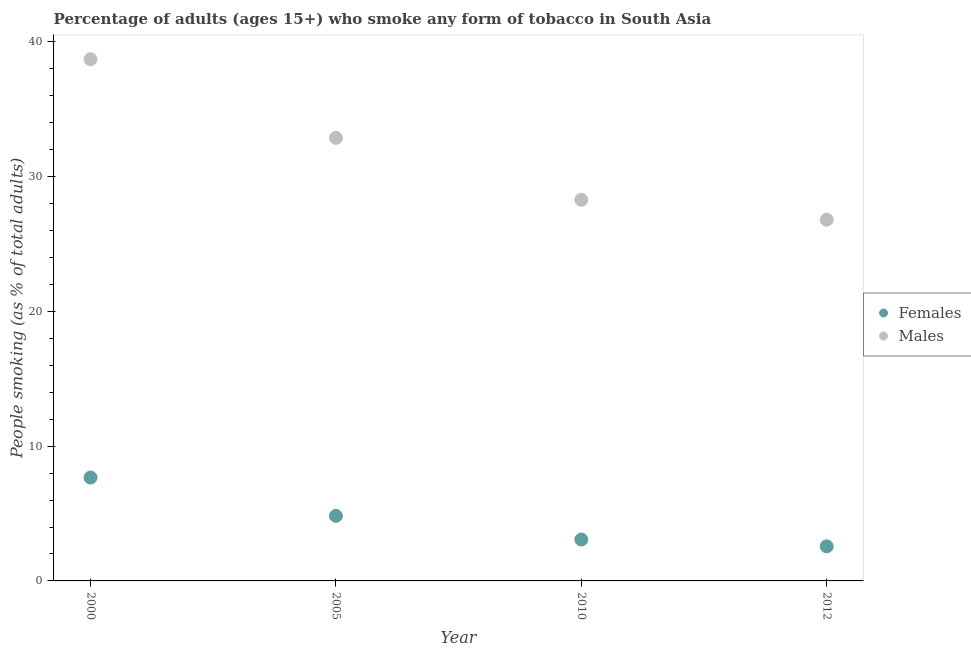How many different coloured dotlines are there?
Ensure brevity in your answer.  2. What is the percentage of males who smoke in 2010?
Provide a succinct answer. 28.29. Across all years, what is the maximum percentage of males who smoke?
Make the answer very short. 38.72. Across all years, what is the minimum percentage of females who smoke?
Offer a terse response. 2.56. In which year was the percentage of females who smoke maximum?
Keep it short and to the point. 2000. In which year was the percentage of males who smoke minimum?
Offer a very short reply. 2012. What is the total percentage of males who smoke in the graph?
Keep it short and to the point. 126.71. What is the difference between the percentage of females who smoke in 2010 and that in 2012?
Your answer should be compact. 0.51. What is the difference between the percentage of males who smoke in 2010 and the percentage of females who smoke in 2005?
Keep it short and to the point. 23.46. What is the average percentage of males who smoke per year?
Provide a short and direct response. 31.68. In the year 2005, what is the difference between the percentage of males who smoke and percentage of females who smoke?
Give a very brief answer. 28.06. What is the ratio of the percentage of males who smoke in 2005 to that in 2012?
Ensure brevity in your answer.  1.23. Is the difference between the percentage of females who smoke in 2000 and 2005 greater than the difference between the percentage of males who smoke in 2000 and 2005?
Ensure brevity in your answer.  No. What is the difference between the highest and the second highest percentage of males who smoke?
Your response must be concise. 5.83. What is the difference between the highest and the lowest percentage of males who smoke?
Provide a succinct answer. 11.91. Is the sum of the percentage of males who smoke in 2005 and 2010 greater than the maximum percentage of females who smoke across all years?
Ensure brevity in your answer.  Yes. Is the percentage of females who smoke strictly greater than the percentage of males who smoke over the years?
Provide a succinct answer. No. What is the difference between two consecutive major ticks on the Y-axis?
Offer a very short reply. 10. Are the values on the major ticks of Y-axis written in scientific E-notation?
Offer a terse response. No. Does the graph contain any zero values?
Provide a short and direct response. No. Does the graph contain grids?
Offer a very short reply. No. Where does the legend appear in the graph?
Offer a terse response. Center right. How many legend labels are there?
Ensure brevity in your answer.  2. What is the title of the graph?
Provide a short and direct response. Percentage of adults (ages 15+) who smoke any form of tobacco in South Asia. Does "Private funds" appear as one of the legend labels in the graph?
Your response must be concise. No. What is the label or title of the Y-axis?
Keep it short and to the point. People smoking (as % of total adults). What is the People smoking (as % of total adults) of Females in 2000?
Provide a succinct answer. 7.67. What is the People smoking (as % of total adults) of Males in 2000?
Give a very brief answer. 38.72. What is the People smoking (as % of total adults) in Females in 2005?
Offer a terse response. 4.83. What is the People smoking (as % of total adults) of Males in 2005?
Provide a succinct answer. 32.89. What is the People smoking (as % of total adults) of Females in 2010?
Keep it short and to the point. 3.07. What is the People smoking (as % of total adults) in Males in 2010?
Your response must be concise. 28.29. What is the People smoking (as % of total adults) of Females in 2012?
Your answer should be very brief. 2.56. What is the People smoking (as % of total adults) in Males in 2012?
Give a very brief answer. 26.81. Across all years, what is the maximum People smoking (as % of total adults) of Females?
Make the answer very short. 7.67. Across all years, what is the maximum People smoking (as % of total adults) in Males?
Your answer should be compact. 38.72. Across all years, what is the minimum People smoking (as % of total adults) of Females?
Keep it short and to the point. 2.56. Across all years, what is the minimum People smoking (as % of total adults) of Males?
Provide a short and direct response. 26.81. What is the total People smoking (as % of total adults) of Females in the graph?
Provide a short and direct response. 18.14. What is the total People smoking (as % of total adults) in Males in the graph?
Offer a very short reply. 126.71. What is the difference between the People smoking (as % of total adults) in Females in 2000 and that in 2005?
Offer a very short reply. 2.84. What is the difference between the People smoking (as % of total adults) in Males in 2000 and that in 2005?
Offer a terse response. 5.83. What is the difference between the People smoking (as % of total adults) of Females in 2000 and that in 2010?
Offer a terse response. 4.6. What is the difference between the People smoking (as % of total adults) of Males in 2000 and that in 2010?
Your response must be concise. 10.43. What is the difference between the People smoking (as % of total adults) of Females in 2000 and that in 2012?
Your response must be concise. 5.11. What is the difference between the People smoking (as % of total adults) in Males in 2000 and that in 2012?
Offer a terse response. 11.91. What is the difference between the People smoking (as % of total adults) of Females in 2005 and that in 2010?
Ensure brevity in your answer.  1.76. What is the difference between the People smoking (as % of total adults) of Males in 2005 and that in 2010?
Provide a short and direct response. 4.6. What is the difference between the People smoking (as % of total adults) in Females in 2005 and that in 2012?
Offer a very short reply. 2.26. What is the difference between the People smoking (as % of total adults) of Males in 2005 and that in 2012?
Make the answer very short. 6.08. What is the difference between the People smoking (as % of total adults) of Females in 2010 and that in 2012?
Make the answer very short. 0.51. What is the difference between the People smoking (as % of total adults) in Males in 2010 and that in 2012?
Make the answer very short. 1.48. What is the difference between the People smoking (as % of total adults) of Females in 2000 and the People smoking (as % of total adults) of Males in 2005?
Give a very brief answer. -25.21. What is the difference between the People smoking (as % of total adults) in Females in 2000 and the People smoking (as % of total adults) in Males in 2010?
Provide a succinct answer. -20.62. What is the difference between the People smoking (as % of total adults) of Females in 2000 and the People smoking (as % of total adults) of Males in 2012?
Provide a succinct answer. -19.14. What is the difference between the People smoking (as % of total adults) in Females in 2005 and the People smoking (as % of total adults) in Males in 2010?
Keep it short and to the point. -23.46. What is the difference between the People smoking (as % of total adults) in Females in 2005 and the People smoking (as % of total adults) in Males in 2012?
Keep it short and to the point. -21.98. What is the difference between the People smoking (as % of total adults) of Females in 2010 and the People smoking (as % of total adults) of Males in 2012?
Offer a terse response. -23.74. What is the average People smoking (as % of total adults) in Females per year?
Your answer should be very brief. 4.53. What is the average People smoking (as % of total adults) in Males per year?
Keep it short and to the point. 31.68. In the year 2000, what is the difference between the People smoking (as % of total adults) in Females and People smoking (as % of total adults) in Males?
Your answer should be compact. -31.05. In the year 2005, what is the difference between the People smoking (as % of total adults) in Females and People smoking (as % of total adults) in Males?
Make the answer very short. -28.06. In the year 2010, what is the difference between the People smoking (as % of total adults) of Females and People smoking (as % of total adults) of Males?
Keep it short and to the point. -25.22. In the year 2012, what is the difference between the People smoking (as % of total adults) of Females and People smoking (as % of total adults) of Males?
Your answer should be very brief. -24.24. What is the ratio of the People smoking (as % of total adults) in Females in 2000 to that in 2005?
Your answer should be very brief. 1.59. What is the ratio of the People smoking (as % of total adults) in Males in 2000 to that in 2005?
Ensure brevity in your answer.  1.18. What is the ratio of the People smoking (as % of total adults) in Females in 2000 to that in 2010?
Offer a terse response. 2.5. What is the ratio of the People smoking (as % of total adults) of Males in 2000 to that in 2010?
Provide a short and direct response. 1.37. What is the ratio of the People smoking (as % of total adults) in Females in 2000 to that in 2012?
Your answer should be very brief. 2.99. What is the ratio of the People smoking (as % of total adults) of Males in 2000 to that in 2012?
Give a very brief answer. 1.44. What is the ratio of the People smoking (as % of total adults) of Females in 2005 to that in 2010?
Your answer should be compact. 1.57. What is the ratio of the People smoking (as % of total adults) in Males in 2005 to that in 2010?
Provide a succinct answer. 1.16. What is the ratio of the People smoking (as % of total adults) of Females in 2005 to that in 2012?
Give a very brief answer. 1.88. What is the ratio of the People smoking (as % of total adults) in Males in 2005 to that in 2012?
Provide a short and direct response. 1.23. What is the ratio of the People smoking (as % of total adults) in Females in 2010 to that in 2012?
Keep it short and to the point. 1.2. What is the ratio of the People smoking (as % of total adults) in Males in 2010 to that in 2012?
Make the answer very short. 1.06. What is the difference between the highest and the second highest People smoking (as % of total adults) of Females?
Give a very brief answer. 2.84. What is the difference between the highest and the second highest People smoking (as % of total adults) in Males?
Provide a succinct answer. 5.83. What is the difference between the highest and the lowest People smoking (as % of total adults) of Females?
Make the answer very short. 5.11. What is the difference between the highest and the lowest People smoking (as % of total adults) of Males?
Your answer should be compact. 11.91. 